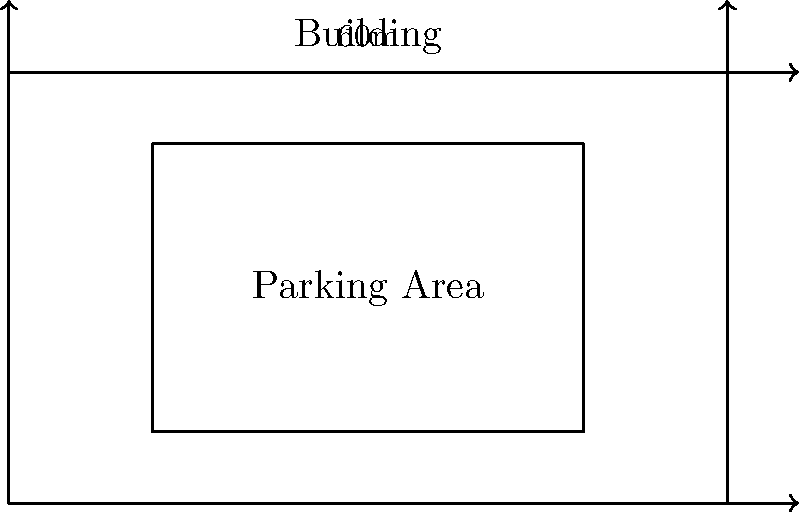You are planning a luxury residential complex in Paris with a limited parking area. The building occupies a 100m by 60m plot, with a central structure leaving a 2m wide strip around its perimeter for parking. Each parking space requires a minimum of 5m by 2.5m. What is the maximum number of parking spaces that can be accommodated in this arrangement? Let's approach this step-by-step:

1) First, we need to calculate the available parking area:
   - Total plot size: 100m × 60m = 6000 m²
   - Building size: 96m × 56m = 5376 m² (subtracting 2m on each side)
   - Available parking area: 6000 m² - 5376 m² = 624 m²

2) Now, let's consider the parking space dimensions:
   - Each parking space needs: 5m × 2.5m = 12.5 m²

3) We need to consider the layout of the parking spaces:
   - Along the 100m sides: We can fit $\lfloor \frac{100}{5} \rfloor = 20$ spaces
   - Along the 60m sides: We can fit $\lfloor \frac{60}{5} \rfloor = 12$ spaces

4) Total spaces along the perimeter:
   - (20 + 20 + 12 + 12) = 64 spaces

5) We need to subtract the corner spaces to avoid double-counting:
   - 64 - 4 = 60 spaces

Therefore, the maximum number of parking spaces that can be accommodated is 60.
Answer: 60 parking spaces 